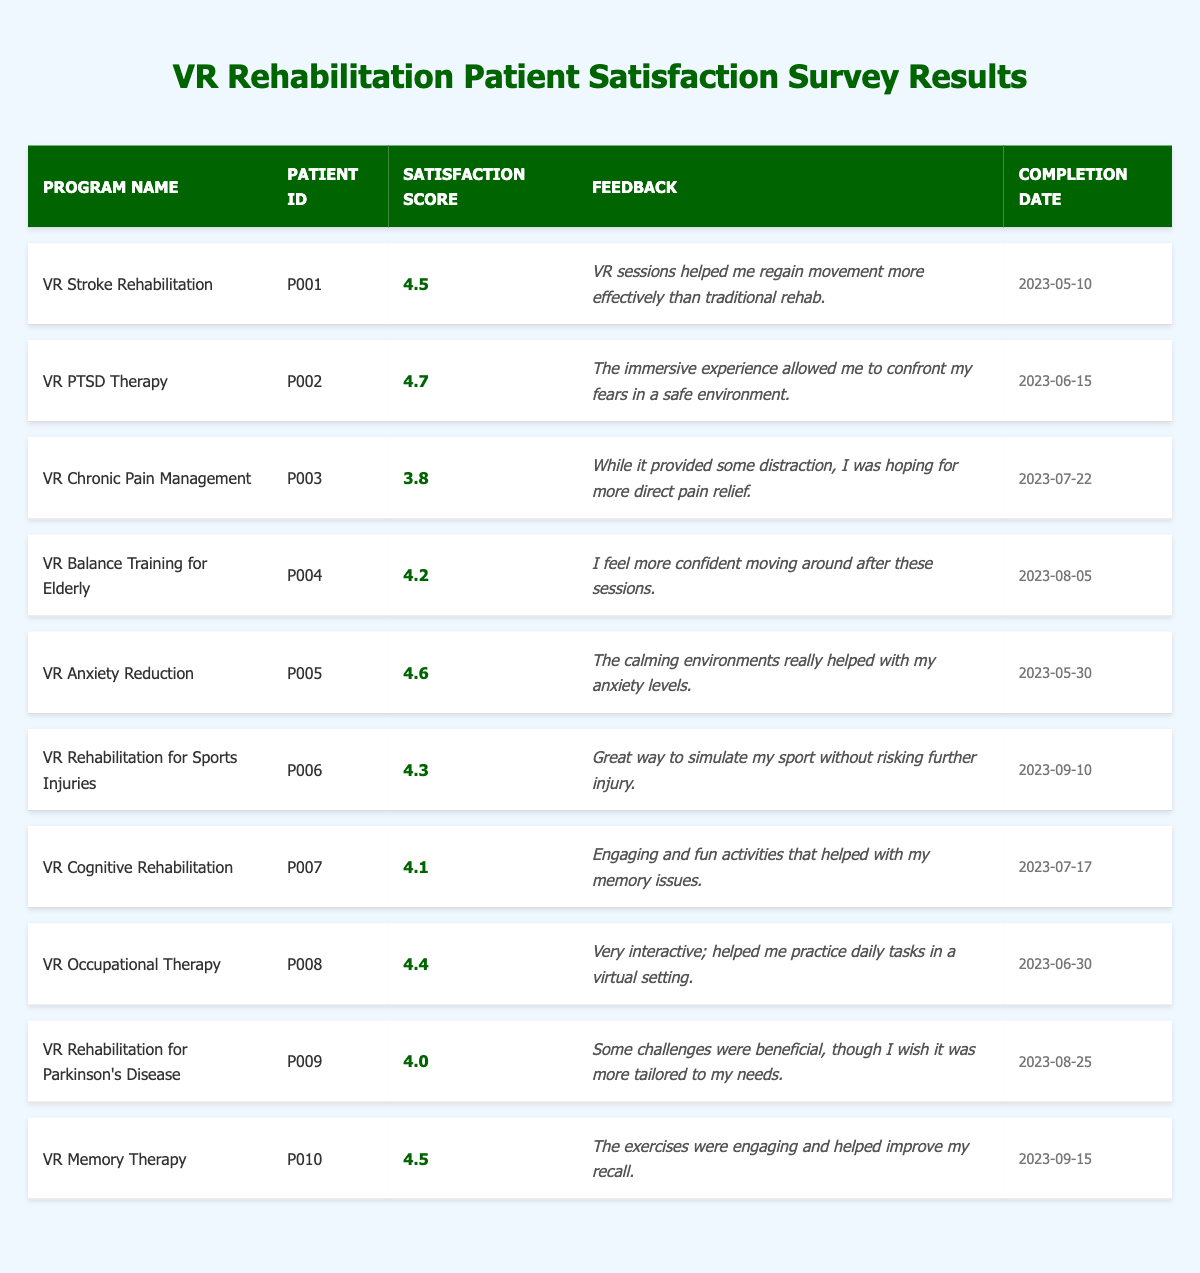What is the highest satisfaction score among the programs? The highest satisfaction score in the table is identified by reviewing the "Satisfaction Score" column. Checking each score, we find that the highest score is 4.7 for the "VR PTSD Therapy" program.
Answer: 4.7 Which program had the lowest satisfaction score? By examining the "Satisfaction Score" in the table, we see that the lowest score is 3.8 for the "VR Chronic Pain Management" program, indicating that it had the lowest patient satisfaction among the listed programs.
Answer: VR Chronic Pain Management How many programs received a satisfaction score of 4.5 or higher? We count the programs with scores of 4.5 or higher by reviewing the "Satisfaction Score" column. The qualifying scores are 4.5 (two instances), 4.7, 4.6, 4.4, 4.3, and 4.2, totaling six programs.
Answer: 6 What is the average satisfaction score of all the programs? To find the average score, we sum all satisfaction scores: 4.5 + 4.7 + 3.8 + 4.2 + 4.6 + 4.3 + 4.1 + 4.4 + 4.0 + 4.5 = 44.1. There are 10 programs, so the average is 44.1 / 10 = 4.41.
Answer: 4.41 Did any program receive feedback indicating it was not tailored to the patient's needs? We look for feedback in the table mentioning a lack of tailoring or personalization. The "VR Rehabilitation for Parkinson's Disease" feedback states a desire for more tailored challenges, confirming that at least one program had such feedback.
Answer: Yes Which program's feedback suggests effective movement recovery? The feedback for "VR Stroke Rehabilitation" states that it helped the patient regain movement effectively, indicating satisfaction related to movement recovery.
Answer: VR Stroke Rehabilitation What is the completion date of the "VR Cognitive Rehabilitation" program? By looking at the "Completion Date" column, the date for "VR Cognitive Rehabilitation" is listed as 2023-07-17.
Answer: 2023-07-17 Which two programs had the closest satisfaction scores? We compare satisfaction scores to identify which two are closest. The scores of "VR Cognitive Rehabilitation" (4.1) and "VR Rehabilitation for Parkinson's Disease" (4.0) have the smallest difference of 0.1, making them the closest.
Answer: VR Cognitive Rehabilitation and VR Rehabilitation for Parkinson's Disease What percentage of the programs scored 4.0 or above? We count programs with scores of 4.0 or above. Eight out of ten programs meet this criterion. The percentage is therefore (8/10) * 100 = 80%.
Answer: 80% Which feedback indicates a positive experience with immersive environments? The feedback for "VR PTSD Therapy" highlights the effectiveness of immersive experiences for confronting fears, showing a positive impression of the immersive aspect.
Answer: VR PTSD Therapy 